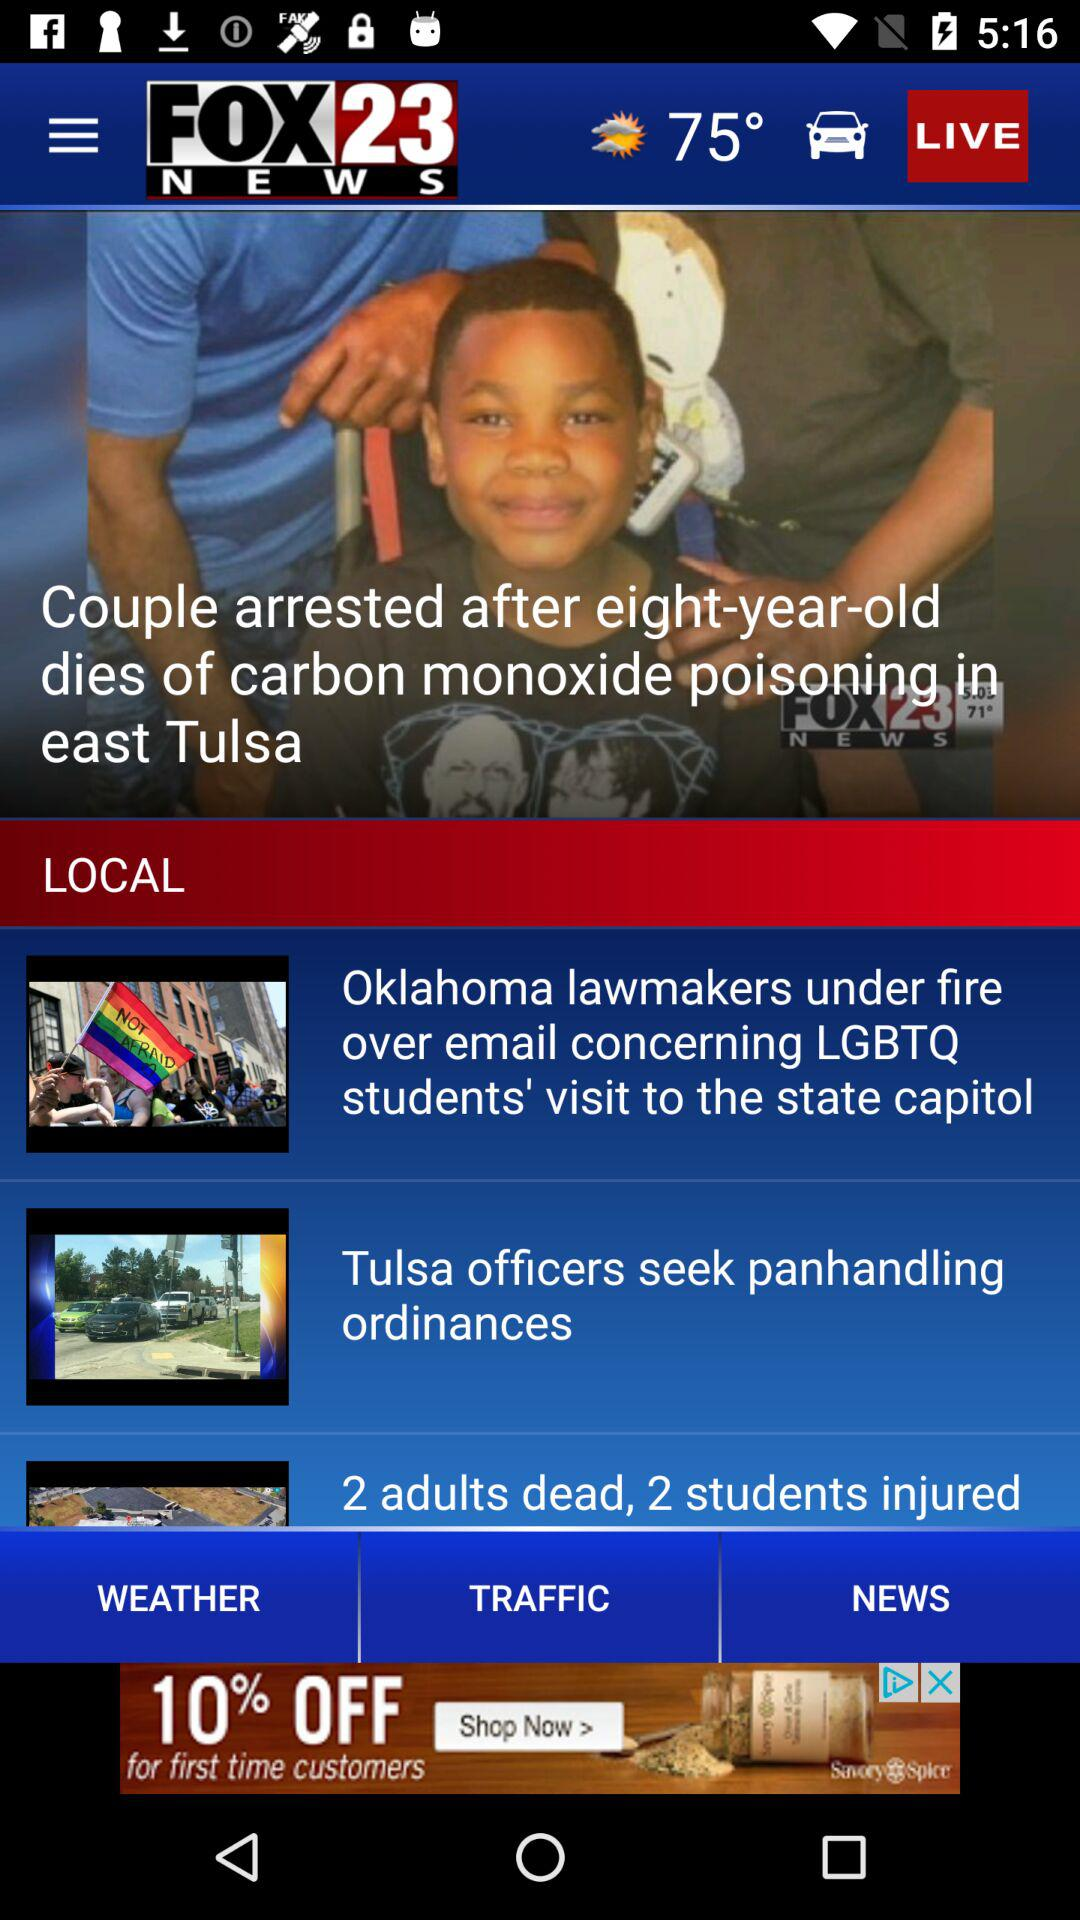What is the temperature today? The temperature today is 75°. 